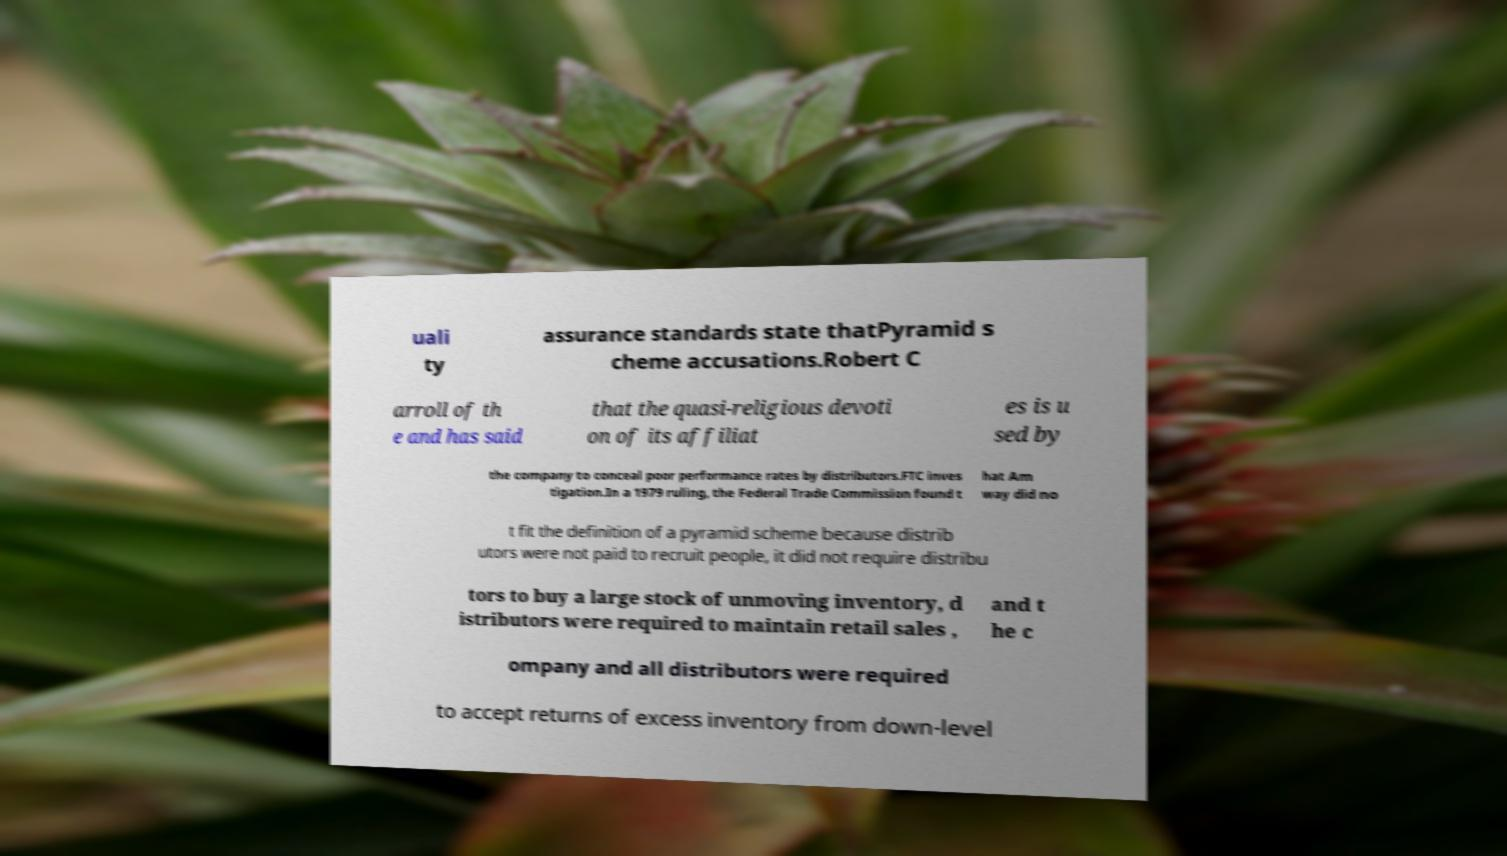For documentation purposes, I need the text within this image transcribed. Could you provide that? uali ty assurance standards state thatPyramid s cheme accusations.Robert C arroll of th e and has said that the quasi-religious devoti on of its affiliat es is u sed by the company to conceal poor performance rates by distributors.FTC inves tigation.In a 1979 ruling, the Federal Trade Commission found t hat Am way did no t fit the definition of a pyramid scheme because distrib utors were not paid to recruit people, it did not require distribu tors to buy a large stock of unmoving inventory, d istributors were required to maintain retail sales , and t he c ompany and all distributors were required to accept returns of excess inventory from down-level 